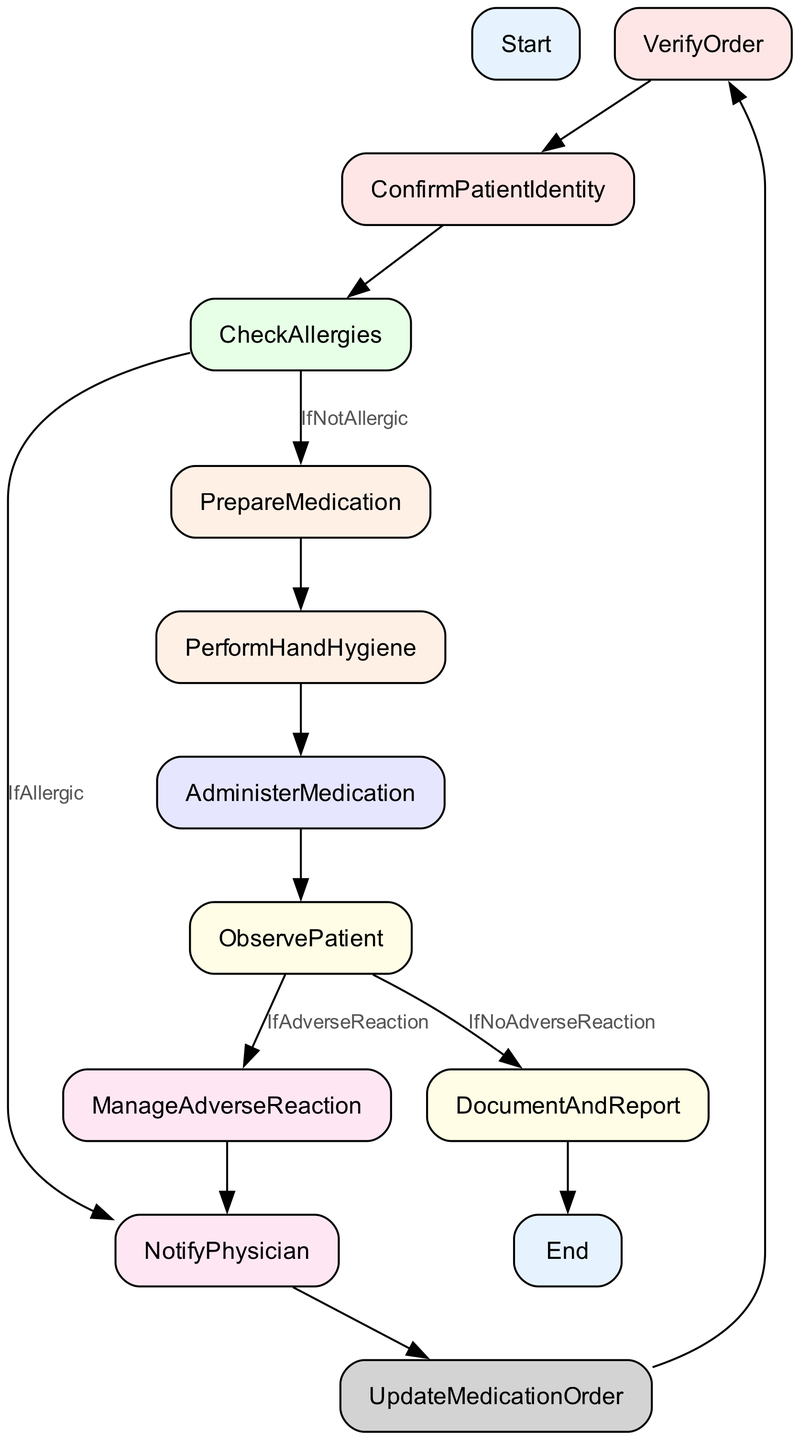What's the initial step in the Medication Administration Protocol? The initial step in the protocol is labeled as "Start". This indicates that it is the beginning of the medication administration process.
Answer: Start How many steps follow after verifying the physician's order? After "VerifyOrder", there is one step directly followed, which is "ConfirmPatientIdentity". Therefore, only one step follows.
Answer: 1 What happens if allergies are found during the check? If allergies are found during the "CheckAllergies" step, the next step is "NotifyPhysician". This means that the physician needs to be informed of the identified allergies.
Answer: NotifyPhysician What is the last step in the Medication Administration Protocol? The last step in the protocol is labeled as "End". This indicates the completion of the medication administration process.
Answer: End If there is no adverse reaction, what is the next step? If there is no adverse reaction following "ObservePatient", the flowchart indicates that the next step is "DocumentAndReport". This involves recording the medication administration details.
Answer: DocumentAndReport How many conditional branches occur after checking allergies? After "CheckAllergies", there are two conditional branches based on the patient's allergy status: "IfAllergic" leading to "NotifyPhysician" and "IfNotAllergic" leading to "PrepareMedication". Thus, there are two branches.
Answer: 2 What action is taken first before administering the medication? Before administering the medication in "AdministerMedication", the first action required is performing hand hygiene, which is noted as "PerformHandHygiene". This is crucial for infection control prior to medication delivery.
Answer: PerformHandHygiene Which step comes after preparing the medication? After "PrepareMedication", the next step in the protocol is "PerformHandHygiene". This is essential to ensure cleanliness before medication administration.
Answer: PerformHandHygiene 